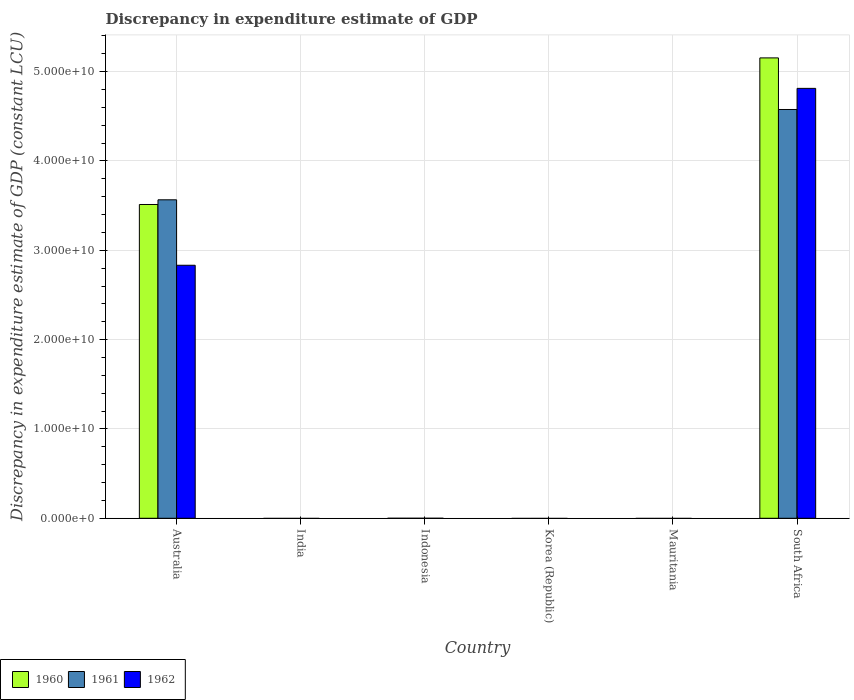Are the number of bars per tick equal to the number of legend labels?
Provide a short and direct response. No. How many bars are there on the 6th tick from the right?
Offer a terse response. 3. What is the label of the 3rd group of bars from the left?
Provide a succinct answer. Indonesia. In how many cases, is the number of bars for a given country not equal to the number of legend labels?
Keep it short and to the point. 4. What is the discrepancy in expenditure estimate of GDP in 1960 in Korea (Republic)?
Provide a succinct answer. 0. Across all countries, what is the maximum discrepancy in expenditure estimate of GDP in 1961?
Provide a succinct answer. 4.58e+1. In which country was the discrepancy in expenditure estimate of GDP in 1961 maximum?
Provide a succinct answer. South Africa. What is the total discrepancy in expenditure estimate of GDP in 1962 in the graph?
Your response must be concise. 7.64e+1. What is the difference between the discrepancy in expenditure estimate of GDP in 1960 in Korea (Republic) and the discrepancy in expenditure estimate of GDP in 1961 in Indonesia?
Offer a very short reply. 0. What is the average discrepancy in expenditure estimate of GDP in 1960 per country?
Your response must be concise. 1.44e+1. What is the difference between the discrepancy in expenditure estimate of GDP of/in 1961 and discrepancy in expenditure estimate of GDP of/in 1962 in South Africa?
Provide a short and direct response. -2.37e+09. What is the difference between the highest and the lowest discrepancy in expenditure estimate of GDP in 1961?
Give a very brief answer. 4.58e+1. In how many countries, is the discrepancy in expenditure estimate of GDP in 1962 greater than the average discrepancy in expenditure estimate of GDP in 1962 taken over all countries?
Offer a terse response. 2. Is it the case that in every country, the sum of the discrepancy in expenditure estimate of GDP in 1962 and discrepancy in expenditure estimate of GDP in 1960 is greater than the discrepancy in expenditure estimate of GDP in 1961?
Your answer should be very brief. No. What is the difference between two consecutive major ticks on the Y-axis?
Provide a succinct answer. 1.00e+1. Does the graph contain any zero values?
Your answer should be compact. Yes. Does the graph contain grids?
Offer a terse response. Yes. What is the title of the graph?
Ensure brevity in your answer.  Discrepancy in expenditure estimate of GDP. What is the label or title of the Y-axis?
Keep it short and to the point. Discrepancy in expenditure estimate of GDP (constant LCU). What is the Discrepancy in expenditure estimate of GDP (constant LCU) in 1960 in Australia?
Offer a terse response. 3.51e+1. What is the Discrepancy in expenditure estimate of GDP (constant LCU) of 1961 in Australia?
Your answer should be very brief. 3.56e+1. What is the Discrepancy in expenditure estimate of GDP (constant LCU) in 1962 in Australia?
Provide a short and direct response. 2.83e+1. What is the Discrepancy in expenditure estimate of GDP (constant LCU) in 1961 in India?
Provide a short and direct response. 0. What is the Discrepancy in expenditure estimate of GDP (constant LCU) of 1960 in Indonesia?
Provide a succinct answer. 0. What is the Discrepancy in expenditure estimate of GDP (constant LCU) of 1962 in Indonesia?
Your answer should be compact. 0. What is the Discrepancy in expenditure estimate of GDP (constant LCU) of 1961 in Korea (Republic)?
Offer a very short reply. 0. What is the Discrepancy in expenditure estimate of GDP (constant LCU) in 1962 in Mauritania?
Ensure brevity in your answer.  0. What is the Discrepancy in expenditure estimate of GDP (constant LCU) of 1960 in South Africa?
Your answer should be compact. 5.15e+1. What is the Discrepancy in expenditure estimate of GDP (constant LCU) in 1961 in South Africa?
Make the answer very short. 4.58e+1. What is the Discrepancy in expenditure estimate of GDP (constant LCU) of 1962 in South Africa?
Keep it short and to the point. 4.81e+1. Across all countries, what is the maximum Discrepancy in expenditure estimate of GDP (constant LCU) in 1960?
Give a very brief answer. 5.15e+1. Across all countries, what is the maximum Discrepancy in expenditure estimate of GDP (constant LCU) in 1961?
Provide a short and direct response. 4.58e+1. Across all countries, what is the maximum Discrepancy in expenditure estimate of GDP (constant LCU) of 1962?
Give a very brief answer. 4.81e+1. Across all countries, what is the minimum Discrepancy in expenditure estimate of GDP (constant LCU) in 1961?
Ensure brevity in your answer.  0. What is the total Discrepancy in expenditure estimate of GDP (constant LCU) of 1960 in the graph?
Make the answer very short. 8.67e+1. What is the total Discrepancy in expenditure estimate of GDP (constant LCU) of 1961 in the graph?
Your response must be concise. 8.14e+1. What is the total Discrepancy in expenditure estimate of GDP (constant LCU) of 1962 in the graph?
Keep it short and to the point. 7.64e+1. What is the difference between the Discrepancy in expenditure estimate of GDP (constant LCU) in 1960 in Australia and that in South Africa?
Offer a very short reply. -1.64e+1. What is the difference between the Discrepancy in expenditure estimate of GDP (constant LCU) of 1961 in Australia and that in South Africa?
Your answer should be very brief. -1.01e+1. What is the difference between the Discrepancy in expenditure estimate of GDP (constant LCU) of 1962 in Australia and that in South Africa?
Give a very brief answer. -1.98e+1. What is the difference between the Discrepancy in expenditure estimate of GDP (constant LCU) of 1960 in Australia and the Discrepancy in expenditure estimate of GDP (constant LCU) of 1961 in South Africa?
Keep it short and to the point. -1.06e+1. What is the difference between the Discrepancy in expenditure estimate of GDP (constant LCU) in 1960 in Australia and the Discrepancy in expenditure estimate of GDP (constant LCU) in 1962 in South Africa?
Offer a very short reply. -1.30e+1. What is the difference between the Discrepancy in expenditure estimate of GDP (constant LCU) of 1961 in Australia and the Discrepancy in expenditure estimate of GDP (constant LCU) of 1962 in South Africa?
Offer a very short reply. -1.25e+1. What is the average Discrepancy in expenditure estimate of GDP (constant LCU) of 1960 per country?
Ensure brevity in your answer.  1.44e+1. What is the average Discrepancy in expenditure estimate of GDP (constant LCU) in 1961 per country?
Provide a succinct answer. 1.36e+1. What is the average Discrepancy in expenditure estimate of GDP (constant LCU) of 1962 per country?
Make the answer very short. 1.27e+1. What is the difference between the Discrepancy in expenditure estimate of GDP (constant LCU) of 1960 and Discrepancy in expenditure estimate of GDP (constant LCU) of 1961 in Australia?
Give a very brief answer. -5.25e+08. What is the difference between the Discrepancy in expenditure estimate of GDP (constant LCU) in 1960 and Discrepancy in expenditure estimate of GDP (constant LCU) in 1962 in Australia?
Your answer should be very brief. 6.80e+09. What is the difference between the Discrepancy in expenditure estimate of GDP (constant LCU) of 1961 and Discrepancy in expenditure estimate of GDP (constant LCU) of 1962 in Australia?
Offer a terse response. 7.33e+09. What is the difference between the Discrepancy in expenditure estimate of GDP (constant LCU) in 1960 and Discrepancy in expenditure estimate of GDP (constant LCU) in 1961 in South Africa?
Provide a short and direct response. 5.78e+09. What is the difference between the Discrepancy in expenditure estimate of GDP (constant LCU) in 1960 and Discrepancy in expenditure estimate of GDP (constant LCU) in 1962 in South Africa?
Ensure brevity in your answer.  3.41e+09. What is the difference between the Discrepancy in expenditure estimate of GDP (constant LCU) in 1961 and Discrepancy in expenditure estimate of GDP (constant LCU) in 1962 in South Africa?
Your response must be concise. -2.37e+09. What is the ratio of the Discrepancy in expenditure estimate of GDP (constant LCU) in 1960 in Australia to that in South Africa?
Offer a terse response. 0.68. What is the ratio of the Discrepancy in expenditure estimate of GDP (constant LCU) in 1961 in Australia to that in South Africa?
Ensure brevity in your answer.  0.78. What is the ratio of the Discrepancy in expenditure estimate of GDP (constant LCU) of 1962 in Australia to that in South Africa?
Your response must be concise. 0.59. What is the difference between the highest and the lowest Discrepancy in expenditure estimate of GDP (constant LCU) in 1960?
Provide a short and direct response. 5.15e+1. What is the difference between the highest and the lowest Discrepancy in expenditure estimate of GDP (constant LCU) of 1961?
Your answer should be compact. 4.58e+1. What is the difference between the highest and the lowest Discrepancy in expenditure estimate of GDP (constant LCU) in 1962?
Your answer should be very brief. 4.81e+1. 